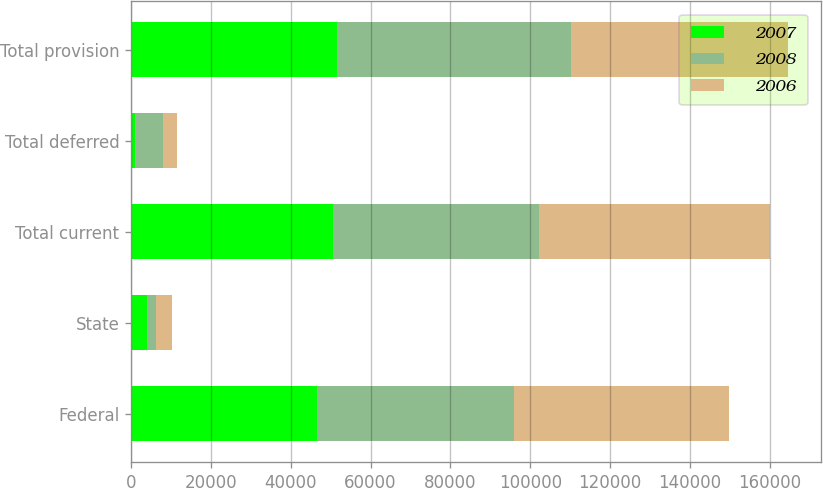<chart> <loc_0><loc_0><loc_500><loc_500><stacked_bar_chart><ecel><fcel>Federal<fcel>State<fcel>Total current<fcel>Total deferred<fcel>Total provision<nl><fcel>2007<fcel>46489<fcel>3995<fcel>50484<fcel>1022<fcel>51506<nl><fcel>2008<fcel>49395<fcel>2321<fcel>51716<fcel>7047<fcel>58763<nl><fcel>2006<fcel>54022<fcel>3832<fcel>57854<fcel>3530<fcel>54324<nl></chart> 